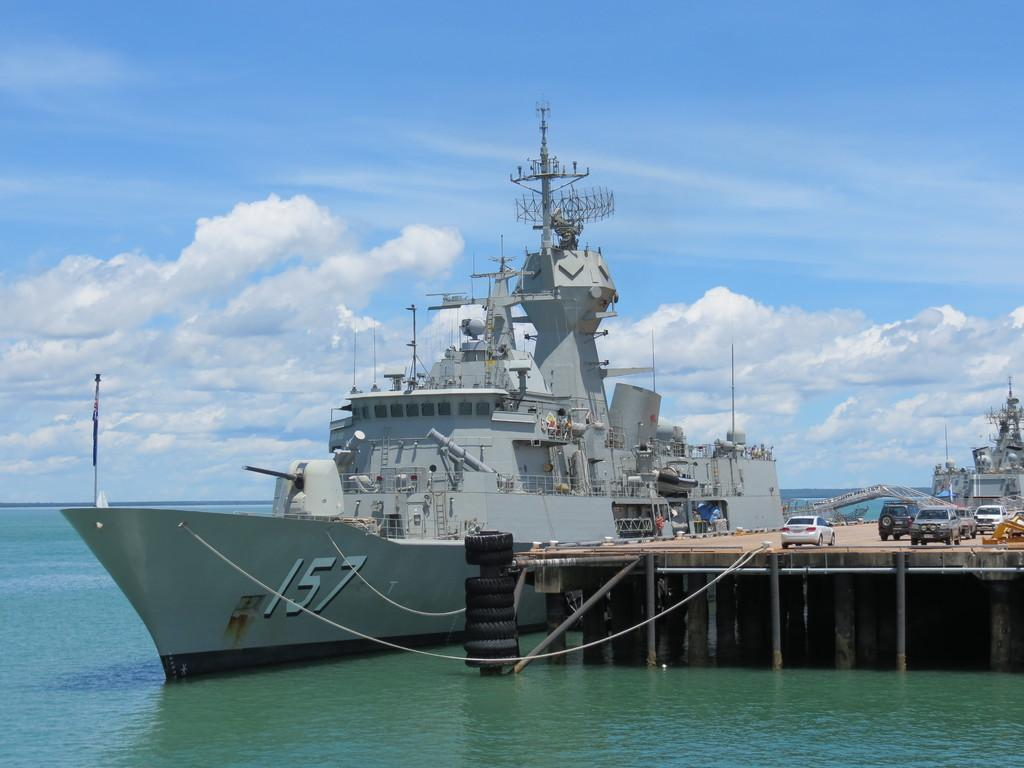What type of vehicles can be seen on the bridge in the image? There are vehicles on a bridge in the image. What is the primary mode of transportation in the water? There are ships in the water. How would you describe the sky in the image? The sky is blue and cloudy. Where is the zoo located in the image? There is no zoo present in the image. What is the answer to the question about the number of stars in the image? There is no question about the number of stars in the image, as there are no stars mentioned in the facts provided. 